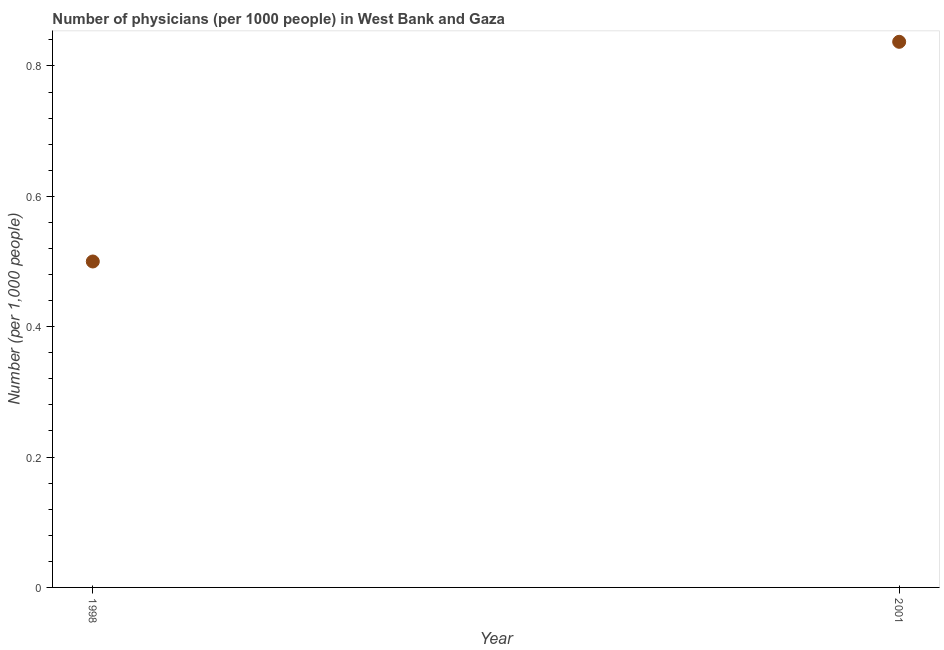Across all years, what is the maximum number of physicians?
Offer a very short reply. 0.84. Across all years, what is the minimum number of physicians?
Provide a succinct answer. 0.5. What is the sum of the number of physicians?
Provide a short and direct response. 1.34. What is the difference between the number of physicians in 1998 and 2001?
Offer a very short reply. -0.34. What is the average number of physicians per year?
Keep it short and to the point. 0.67. What is the median number of physicians?
Ensure brevity in your answer.  0.67. In how many years, is the number of physicians greater than 0.28 ?
Offer a terse response. 2. What is the ratio of the number of physicians in 1998 to that in 2001?
Make the answer very short. 0.6. In how many years, is the number of physicians greater than the average number of physicians taken over all years?
Offer a very short reply. 1. How many dotlines are there?
Offer a terse response. 1. How many years are there in the graph?
Make the answer very short. 2. What is the difference between two consecutive major ticks on the Y-axis?
Make the answer very short. 0.2. What is the title of the graph?
Your answer should be compact. Number of physicians (per 1000 people) in West Bank and Gaza. What is the label or title of the Y-axis?
Give a very brief answer. Number (per 1,0 people). What is the Number (per 1,000 people) in 2001?
Your answer should be compact. 0.84. What is the difference between the Number (per 1,000 people) in 1998 and 2001?
Your answer should be very brief. -0.34. What is the ratio of the Number (per 1,000 people) in 1998 to that in 2001?
Your answer should be compact. 0.6. 